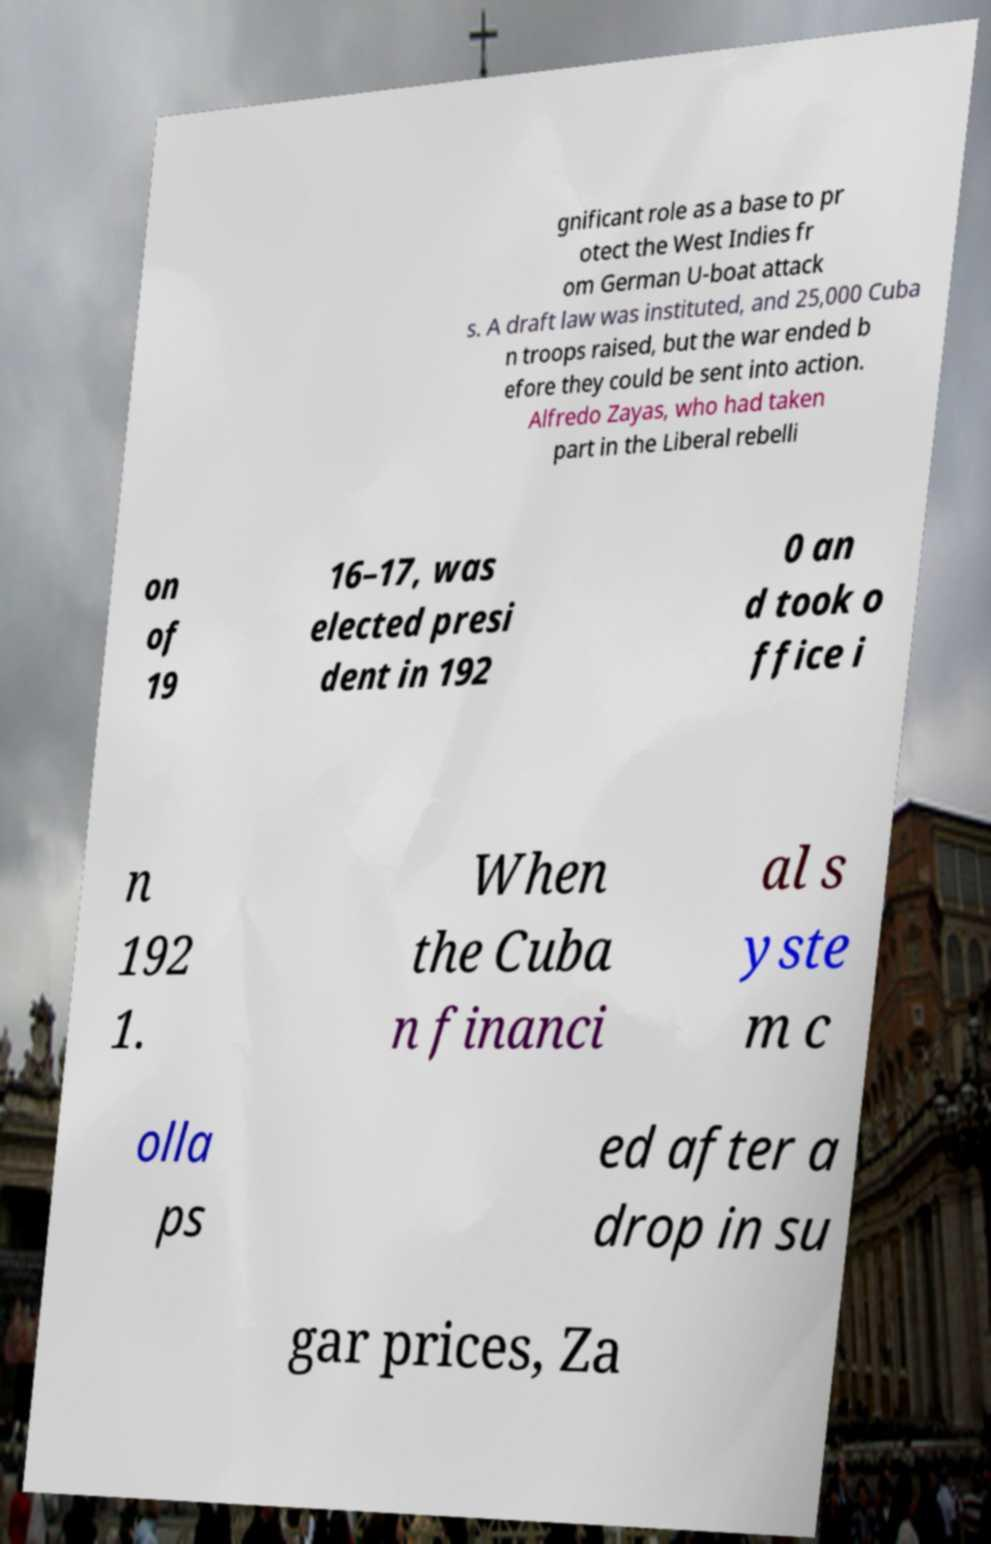There's text embedded in this image that I need extracted. Can you transcribe it verbatim? gnificant role as a base to pr otect the West Indies fr om German U-boat attack s. A draft law was instituted, and 25,000 Cuba n troops raised, but the war ended b efore they could be sent into action. Alfredo Zayas, who had taken part in the Liberal rebelli on of 19 16–17, was elected presi dent in 192 0 an d took o ffice i n 192 1. When the Cuba n financi al s yste m c olla ps ed after a drop in su gar prices, Za 